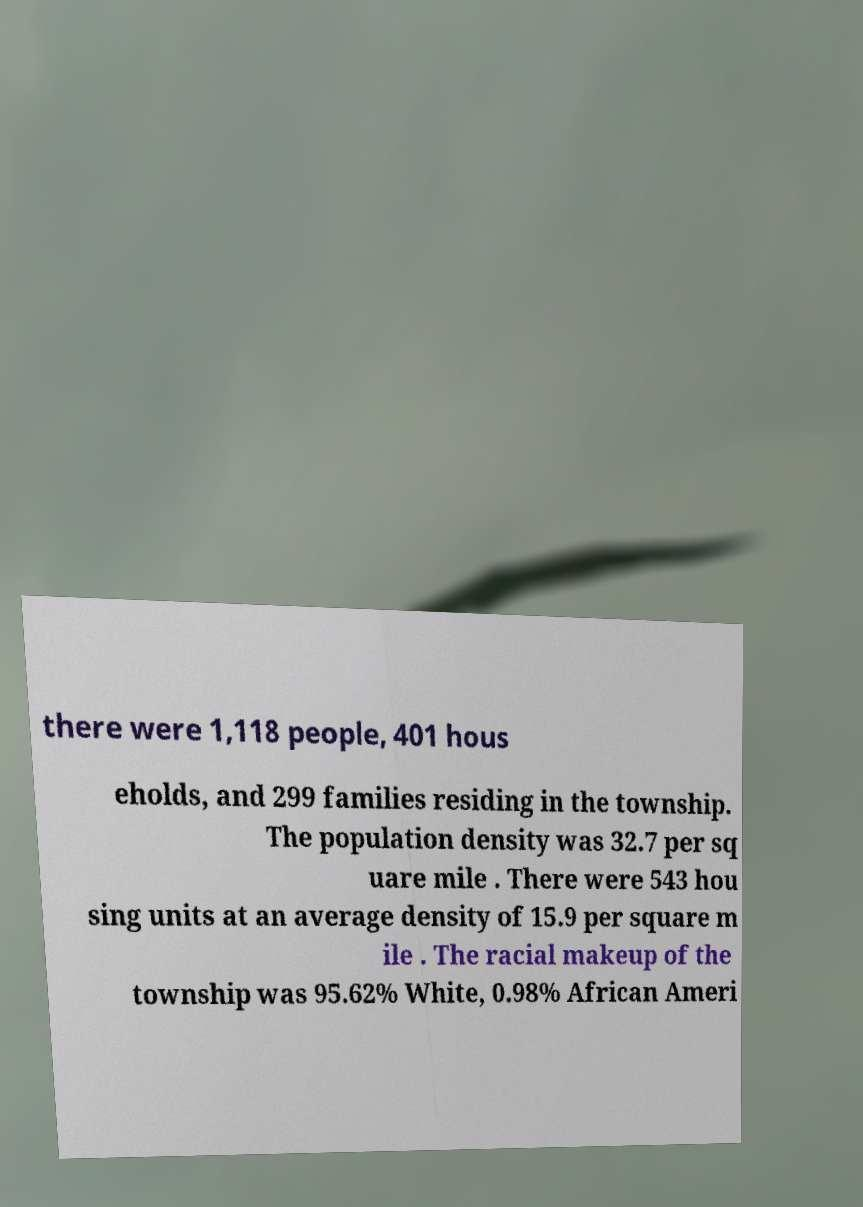I need the written content from this picture converted into text. Can you do that? there were 1,118 people, 401 hous eholds, and 299 families residing in the township. The population density was 32.7 per sq uare mile . There were 543 hou sing units at an average density of 15.9 per square m ile . The racial makeup of the township was 95.62% White, 0.98% African Ameri 